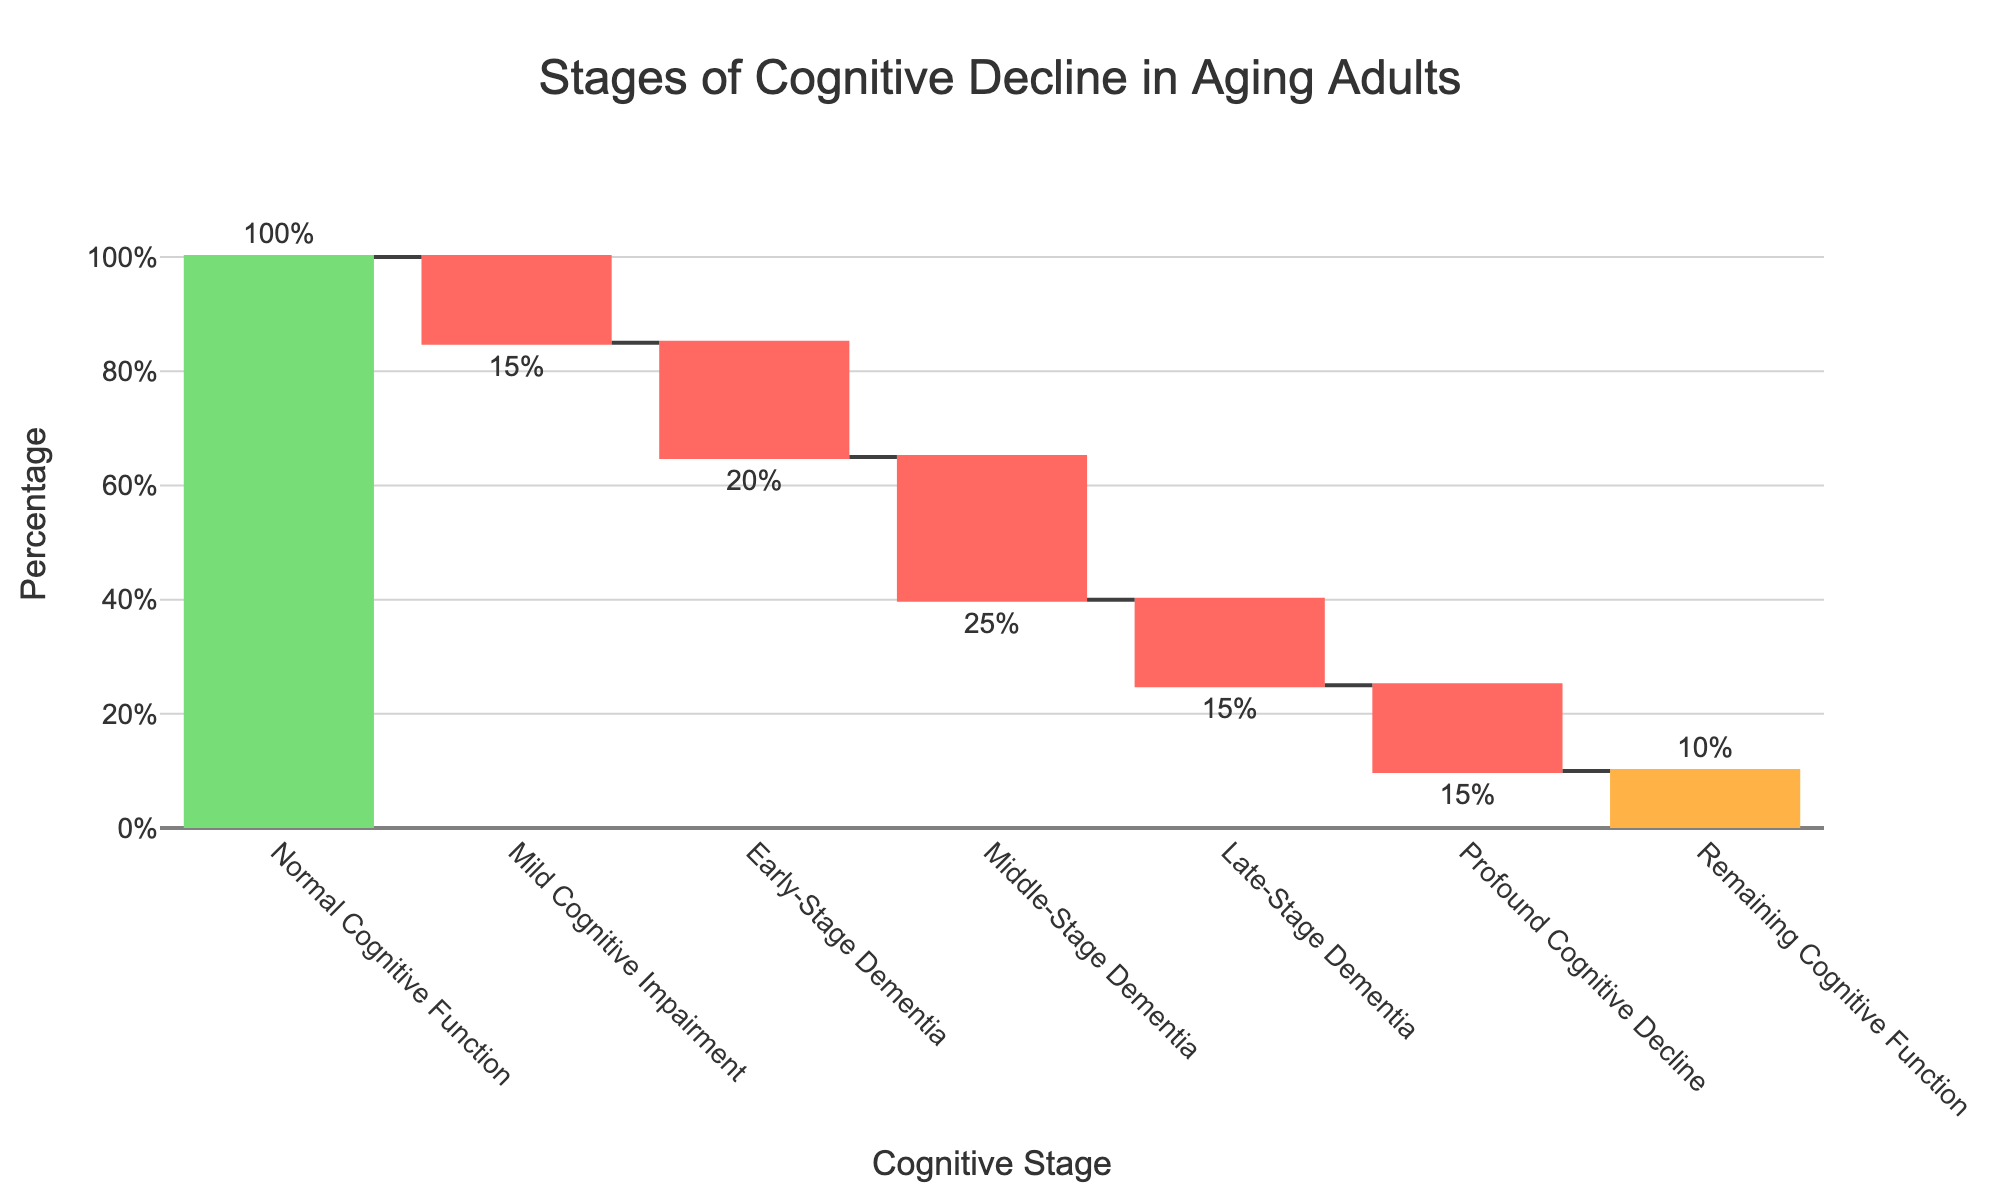What's the title of the figure? The title is usually positioned at the top of the figure, stating the main focus. It reads "Stages of Cognitive Decline in Aging Adults".
Answer: Stages of Cognitive Decline in Aging Adults How many cognitive stages are displayed in the figure? By counting the stages on the x-axis, we see there are six stages displayed, from "Normal Cognitive Function" to "Profound Cognitive Decline".
Answer: Six stages What is the total percentage loss after all the stages of cognitive decline? To find the total percentage loss, sum up the negative percentages: -15% (Mild Cognitive Impairment) + -20% (Early-Stage Dementia) + -25% (Middle-Stage Dementia) + -15% (Late-Stage Dementia) + -15% (Profound Cognitive Decline) = -90%.
Answer: -90% Which stage contributes the most to cognitive decline? By observing the bars, the largest drop corresponds to "Middle-Stage Dementia" with a 25% decline.
Answer: Middle-Stage Dementia How does the percentage of "Normal Cognitive Function" compare to "Remaining Cognitive Function"? "Normal Cognitive Function" starts at 100% while "Remaining Cognitive Function" is 10%. The comparison shows a 90% reduction.
Answer: 90% reduction What do the colors of the bars represent in the figure? The colors indicate different contributions: green for an increase ("Normal Cognitive Function"), red for decreases (various stages of cognitive decline), and orange for the total/remaining value. Hence, "Normal Cognitive Function" is green, decline stages are red, and remaining function is orange.
Answer: Green=increase, Red=Decreases, Orange=Total/Remaining What's the percentage decrease from "Normal Cognitive Function" to "Early-Stage Dementia"? Sum the percentage losses from "Normal Cognitive Function" (100%) through "Early-Stage Dementia": 100% - 15% = 85%; then 85% - 20% = 65%. The decrease is 35%.
Answer: 35% If the cognitive function continues to decline uniformly in "Late-Stage Dementia" and "Profound Cognitive Decline", what is the average percentage decrease for these two stages? Add the percentages for "Late-Stage Dementia" (-15%) and "Profound Cognitive Decline" (-15%), then divide by 2. (-15% + -15%) / 2 = -15%.
Answer: -15% What percentage of cognitive function remains after "Middle-Stage Dementia"? Start with 100%. Subtract each stage's percentage consecutively: -15%, -20%, -25%. This results in 100% - 15% - 20% - 25% = 40%.
Answer: 40% Explain how you can calculate the final remaining cognitive function percentage shown in the figure? Start with 100% and sum up each decrease to get -90%. Then add the remaining 10% shown in the last bar which represents what remains after the decline: 100% - 90% + 10% = 20%.
Answer: 20% 